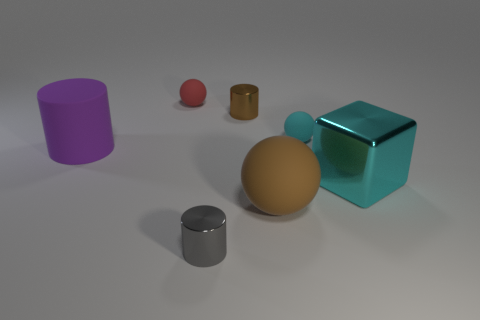Does the large thing in front of the large cyan cube have the same shape as the red matte object?
Your answer should be compact. Yes. Is the number of brown objects left of the brown rubber thing greater than the number of red metal cylinders?
Keep it short and to the point. Yes. What is the color of the tiny sphere to the right of the metallic cylinder right of the gray metal cylinder?
Provide a short and direct response. Cyan. What number of tiny green blocks are there?
Give a very brief answer. 0. How many big things are to the left of the small cyan matte object and in front of the large rubber cylinder?
Your answer should be compact. 1. Is there anything else that has the same shape as the big metallic thing?
Offer a terse response. No. There is a big block; is its color the same as the small rubber ball right of the tiny gray thing?
Provide a succinct answer. Yes. The brown thing that is left of the large brown sphere has what shape?
Your answer should be very brief. Cylinder. How many other objects are the same material as the tiny brown cylinder?
Offer a terse response. 2. What is the material of the purple cylinder?
Give a very brief answer. Rubber. 